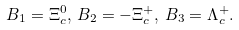<formula> <loc_0><loc_0><loc_500><loc_500>B _ { 1 } = \Xi ^ { 0 } _ { c } , \, B _ { 2 } = - \Xi ^ { + } _ { c } , \, B _ { 3 } = \Lambda ^ { + } _ { c } .</formula> 